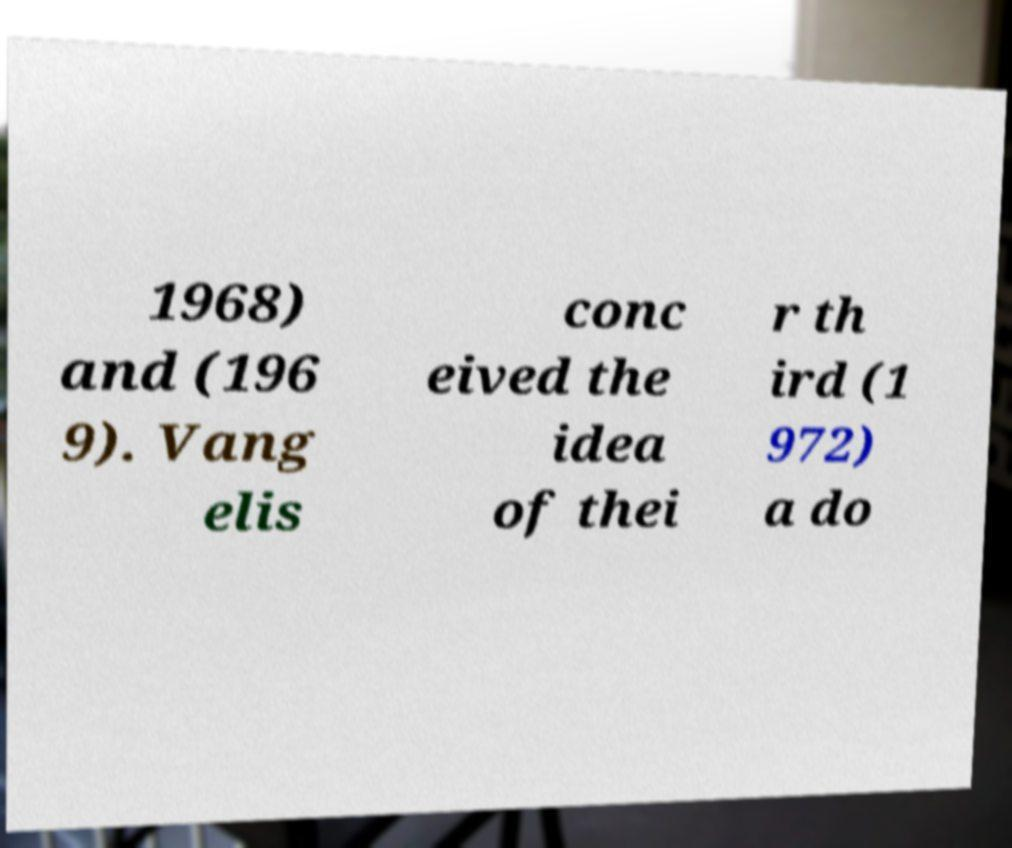Could you assist in decoding the text presented in this image and type it out clearly? 1968) and (196 9). Vang elis conc eived the idea of thei r th ird (1 972) a do 